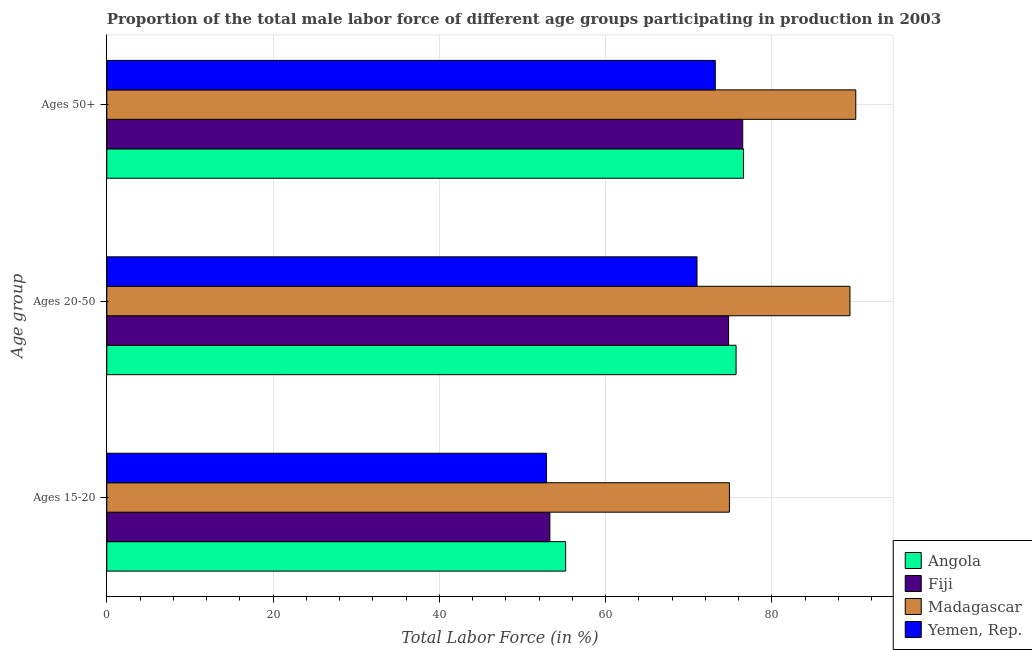How many different coloured bars are there?
Make the answer very short. 4. How many groups of bars are there?
Give a very brief answer. 3. Are the number of bars on each tick of the Y-axis equal?
Keep it short and to the point. Yes. How many bars are there on the 3rd tick from the bottom?
Ensure brevity in your answer.  4. What is the label of the 2nd group of bars from the top?
Give a very brief answer. Ages 20-50. What is the percentage of male labor force within the age group 15-20 in Angola?
Give a very brief answer. 55.2. Across all countries, what is the maximum percentage of male labor force within the age group 20-50?
Offer a very short reply. 89.4. In which country was the percentage of male labor force within the age group 15-20 maximum?
Keep it short and to the point. Madagascar. In which country was the percentage of male labor force above age 50 minimum?
Ensure brevity in your answer.  Yemen, Rep. What is the total percentage of male labor force above age 50 in the graph?
Provide a short and direct response. 316.4. What is the difference between the percentage of male labor force within the age group 20-50 in Yemen, Rep. and that in Angola?
Your answer should be compact. -4.7. What is the difference between the percentage of male labor force within the age group 20-50 in Angola and the percentage of male labor force within the age group 15-20 in Madagascar?
Ensure brevity in your answer.  0.8. What is the average percentage of male labor force above age 50 per country?
Offer a terse response. 79.1. What is the difference between the percentage of male labor force within the age group 15-20 and percentage of male labor force above age 50 in Madagascar?
Your answer should be compact. -15.2. What is the ratio of the percentage of male labor force within the age group 15-20 in Angola to that in Fiji?
Your answer should be very brief. 1.04. Is the percentage of male labor force above age 50 in Madagascar less than that in Yemen, Rep.?
Keep it short and to the point. No. Is the difference between the percentage of male labor force above age 50 in Yemen, Rep. and Angola greater than the difference between the percentage of male labor force within the age group 15-20 in Yemen, Rep. and Angola?
Give a very brief answer. No. What is the difference between the highest and the lowest percentage of male labor force within the age group 20-50?
Offer a terse response. 18.4. Is the sum of the percentage of male labor force within the age group 20-50 in Angola and Madagascar greater than the maximum percentage of male labor force within the age group 15-20 across all countries?
Your answer should be compact. Yes. What does the 3rd bar from the top in Ages 50+ represents?
Make the answer very short. Fiji. What does the 4th bar from the bottom in Ages 50+ represents?
Provide a succinct answer. Yemen, Rep. Is it the case that in every country, the sum of the percentage of male labor force within the age group 15-20 and percentage of male labor force within the age group 20-50 is greater than the percentage of male labor force above age 50?
Offer a very short reply. Yes. Are the values on the major ticks of X-axis written in scientific E-notation?
Your answer should be very brief. No. Does the graph contain any zero values?
Your answer should be very brief. No. How many legend labels are there?
Keep it short and to the point. 4. What is the title of the graph?
Your answer should be compact. Proportion of the total male labor force of different age groups participating in production in 2003. Does "East Asia (developing only)" appear as one of the legend labels in the graph?
Offer a very short reply. No. What is the label or title of the Y-axis?
Your answer should be very brief. Age group. What is the Total Labor Force (in %) in Angola in Ages 15-20?
Give a very brief answer. 55.2. What is the Total Labor Force (in %) in Fiji in Ages 15-20?
Ensure brevity in your answer.  53.3. What is the Total Labor Force (in %) in Madagascar in Ages 15-20?
Make the answer very short. 74.9. What is the Total Labor Force (in %) of Yemen, Rep. in Ages 15-20?
Provide a succinct answer. 52.9. What is the Total Labor Force (in %) of Angola in Ages 20-50?
Offer a very short reply. 75.7. What is the Total Labor Force (in %) of Fiji in Ages 20-50?
Ensure brevity in your answer.  74.8. What is the Total Labor Force (in %) in Madagascar in Ages 20-50?
Your answer should be compact. 89.4. What is the Total Labor Force (in %) of Angola in Ages 50+?
Give a very brief answer. 76.6. What is the Total Labor Force (in %) of Fiji in Ages 50+?
Ensure brevity in your answer.  76.5. What is the Total Labor Force (in %) of Madagascar in Ages 50+?
Your answer should be very brief. 90.1. What is the Total Labor Force (in %) of Yemen, Rep. in Ages 50+?
Give a very brief answer. 73.2. Across all Age group, what is the maximum Total Labor Force (in %) in Angola?
Provide a succinct answer. 76.6. Across all Age group, what is the maximum Total Labor Force (in %) in Fiji?
Offer a very short reply. 76.5. Across all Age group, what is the maximum Total Labor Force (in %) in Madagascar?
Offer a very short reply. 90.1. Across all Age group, what is the maximum Total Labor Force (in %) of Yemen, Rep.?
Make the answer very short. 73.2. Across all Age group, what is the minimum Total Labor Force (in %) of Angola?
Keep it short and to the point. 55.2. Across all Age group, what is the minimum Total Labor Force (in %) of Fiji?
Make the answer very short. 53.3. Across all Age group, what is the minimum Total Labor Force (in %) of Madagascar?
Your answer should be very brief. 74.9. Across all Age group, what is the minimum Total Labor Force (in %) of Yemen, Rep.?
Keep it short and to the point. 52.9. What is the total Total Labor Force (in %) of Angola in the graph?
Make the answer very short. 207.5. What is the total Total Labor Force (in %) of Fiji in the graph?
Give a very brief answer. 204.6. What is the total Total Labor Force (in %) in Madagascar in the graph?
Ensure brevity in your answer.  254.4. What is the total Total Labor Force (in %) of Yemen, Rep. in the graph?
Give a very brief answer. 197.1. What is the difference between the Total Labor Force (in %) in Angola in Ages 15-20 and that in Ages 20-50?
Make the answer very short. -20.5. What is the difference between the Total Labor Force (in %) of Fiji in Ages 15-20 and that in Ages 20-50?
Make the answer very short. -21.5. What is the difference between the Total Labor Force (in %) in Yemen, Rep. in Ages 15-20 and that in Ages 20-50?
Give a very brief answer. -18.1. What is the difference between the Total Labor Force (in %) in Angola in Ages 15-20 and that in Ages 50+?
Ensure brevity in your answer.  -21.4. What is the difference between the Total Labor Force (in %) of Fiji in Ages 15-20 and that in Ages 50+?
Offer a terse response. -23.2. What is the difference between the Total Labor Force (in %) of Madagascar in Ages 15-20 and that in Ages 50+?
Offer a terse response. -15.2. What is the difference between the Total Labor Force (in %) of Yemen, Rep. in Ages 15-20 and that in Ages 50+?
Your answer should be very brief. -20.3. What is the difference between the Total Labor Force (in %) of Angola in Ages 15-20 and the Total Labor Force (in %) of Fiji in Ages 20-50?
Keep it short and to the point. -19.6. What is the difference between the Total Labor Force (in %) in Angola in Ages 15-20 and the Total Labor Force (in %) in Madagascar in Ages 20-50?
Ensure brevity in your answer.  -34.2. What is the difference between the Total Labor Force (in %) of Angola in Ages 15-20 and the Total Labor Force (in %) of Yemen, Rep. in Ages 20-50?
Make the answer very short. -15.8. What is the difference between the Total Labor Force (in %) in Fiji in Ages 15-20 and the Total Labor Force (in %) in Madagascar in Ages 20-50?
Your answer should be very brief. -36.1. What is the difference between the Total Labor Force (in %) in Fiji in Ages 15-20 and the Total Labor Force (in %) in Yemen, Rep. in Ages 20-50?
Offer a very short reply. -17.7. What is the difference between the Total Labor Force (in %) of Madagascar in Ages 15-20 and the Total Labor Force (in %) of Yemen, Rep. in Ages 20-50?
Give a very brief answer. 3.9. What is the difference between the Total Labor Force (in %) of Angola in Ages 15-20 and the Total Labor Force (in %) of Fiji in Ages 50+?
Provide a short and direct response. -21.3. What is the difference between the Total Labor Force (in %) in Angola in Ages 15-20 and the Total Labor Force (in %) in Madagascar in Ages 50+?
Keep it short and to the point. -34.9. What is the difference between the Total Labor Force (in %) of Fiji in Ages 15-20 and the Total Labor Force (in %) of Madagascar in Ages 50+?
Keep it short and to the point. -36.8. What is the difference between the Total Labor Force (in %) in Fiji in Ages 15-20 and the Total Labor Force (in %) in Yemen, Rep. in Ages 50+?
Offer a terse response. -19.9. What is the difference between the Total Labor Force (in %) of Madagascar in Ages 15-20 and the Total Labor Force (in %) of Yemen, Rep. in Ages 50+?
Ensure brevity in your answer.  1.7. What is the difference between the Total Labor Force (in %) in Angola in Ages 20-50 and the Total Labor Force (in %) in Madagascar in Ages 50+?
Offer a very short reply. -14.4. What is the difference between the Total Labor Force (in %) of Angola in Ages 20-50 and the Total Labor Force (in %) of Yemen, Rep. in Ages 50+?
Your response must be concise. 2.5. What is the difference between the Total Labor Force (in %) of Fiji in Ages 20-50 and the Total Labor Force (in %) of Madagascar in Ages 50+?
Provide a short and direct response. -15.3. What is the difference between the Total Labor Force (in %) of Fiji in Ages 20-50 and the Total Labor Force (in %) of Yemen, Rep. in Ages 50+?
Offer a terse response. 1.6. What is the average Total Labor Force (in %) of Angola per Age group?
Provide a succinct answer. 69.17. What is the average Total Labor Force (in %) of Fiji per Age group?
Provide a short and direct response. 68.2. What is the average Total Labor Force (in %) of Madagascar per Age group?
Provide a short and direct response. 84.8. What is the average Total Labor Force (in %) of Yemen, Rep. per Age group?
Give a very brief answer. 65.7. What is the difference between the Total Labor Force (in %) of Angola and Total Labor Force (in %) of Madagascar in Ages 15-20?
Provide a short and direct response. -19.7. What is the difference between the Total Labor Force (in %) of Angola and Total Labor Force (in %) of Yemen, Rep. in Ages 15-20?
Provide a short and direct response. 2.3. What is the difference between the Total Labor Force (in %) of Fiji and Total Labor Force (in %) of Madagascar in Ages 15-20?
Give a very brief answer. -21.6. What is the difference between the Total Labor Force (in %) in Angola and Total Labor Force (in %) in Fiji in Ages 20-50?
Give a very brief answer. 0.9. What is the difference between the Total Labor Force (in %) in Angola and Total Labor Force (in %) in Madagascar in Ages 20-50?
Ensure brevity in your answer.  -13.7. What is the difference between the Total Labor Force (in %) in Fiji and Total Labor Force (in %) in Madagascar in Ages 20-50?
Your answer should be compact. -14.6. What is the difference between the Total Labor Force (in %) in Madagascar and Total Labor Force (in %) in Yemen, Rep. in Ages 20-50?
Provide a succinct answer. 18.4. What is the difference between the Total Labor Force (in %) of Angola and Total Labor Force (in %) of Fiji in Ages 50+?
Keep it short and to the point. 0.1. What is the ratio of the Total Labor Force (in %) in Angola in Ages 15-20 to that in Ages 20-50?
Offer a terse response. 0.73. What is the ratio of the Total Labor Force (in %) in Fiji in Ages 15-20 to that in Ages 20-50?
Your response must be concise. 0.71. What is the ratio of the Total Labor Force (in %) in Madagascar in Ages 15-20 to that in Ages 20-50?
Provide a short and direct response. 0.84. What is the ratio of the Total Labor Force (in %) in Yemen, Rep. in Ages 15-20 to that in Ages 20-50?
Your response must be concise. 0.75. What is the ratio of the Total Labor Force (in %) of Angola in Ages 15-20 to that in Ages 50+?
Your answer should be compact. 0.72. What is the ratio of the Total Labor Force (in %) of Fiji in Ages 15-20 to that in Ages 50+?
Ensure brevity in your answer.  0.7. What is the ratio of the Total Labor Force (in %) of Madagascar in Ages 15-20 to that in Ages 50+?
Ensure brevity in your answer.  0.83. What is the ratio of the Total Labor Force (in %) in Yemen, Rep. in Ages 15-20 to that in Ages 50+?
Your answer should be compact. 0.72. What is the ratio of the Total Labor Force (in %) in Angola in Ages 20-50 to that in Ages 50+?
Your answer should be very brief. 0.99. What is the ratio of the Total Labor Force (in %) in Fiji in Ages 20-50 to that in Ages 50+?
Ensure brevity in your answer.  0.98. What is the ratio of the Total Labor Force (in %) in Yemen, Rep. in Ages 20-50 to that in Ages 50+?
Ensure brevity in your answer.  0.97. What is the difference between the highest and the second highest Total Labor Force (in %) in Angola?
Offer a terse response. 0.9. What is the difference between the highest and the lowest Total Labor Force (in %) of Angola?
Ensure brevity in your answer.  21.4. What is the difference between the highest and the lowest Total Labor Force (in %) in Fiji?
Your answer should be very brief. 23.2. What is the difference between the highest and the lowest Total Labor Force (in %) in Yemen, Rep.?
Keep it short and to the point. 20.3. 